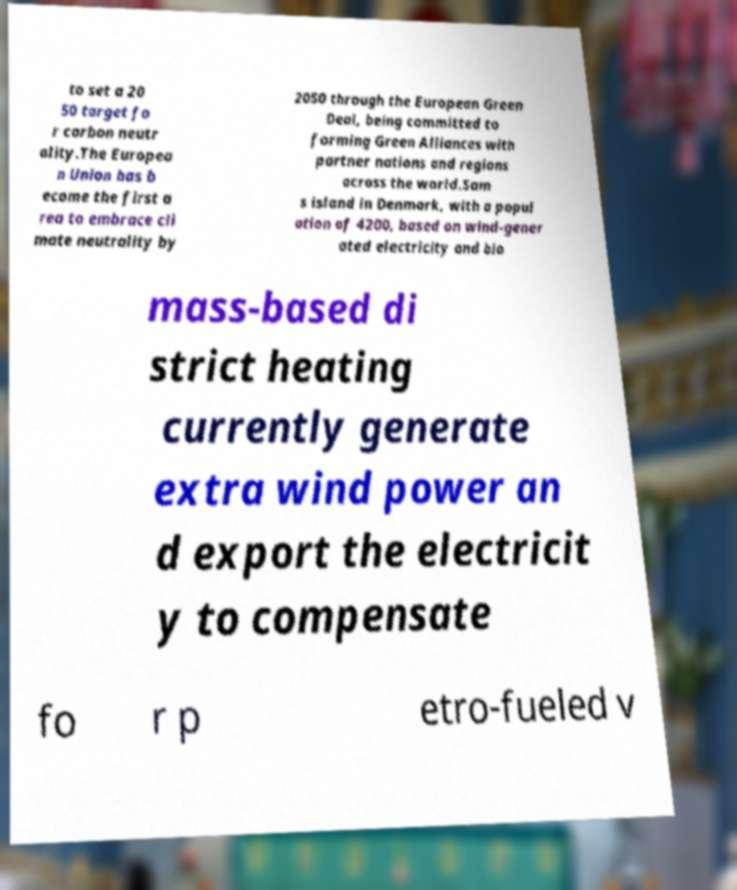Can you read and provide the text displayed in the image?This photo seems to have some interesting text. Can you extract and type it out for me? to set a 20 50 target fo r carbon neutr ality.The Europea n Union has b ecome the first a rea to embrace cli mate neutrality by 2050 through the European Green Deal, being committed to forming Green Alliances with partner nations and regions across the world.Sam s island in Denmark, with a popul ation of 4200, based on wind-gener ated electricity and bio mass-based di strict heating currently generate extra wind power an d export the electricit y to compensate fo r p etro-fueled v 